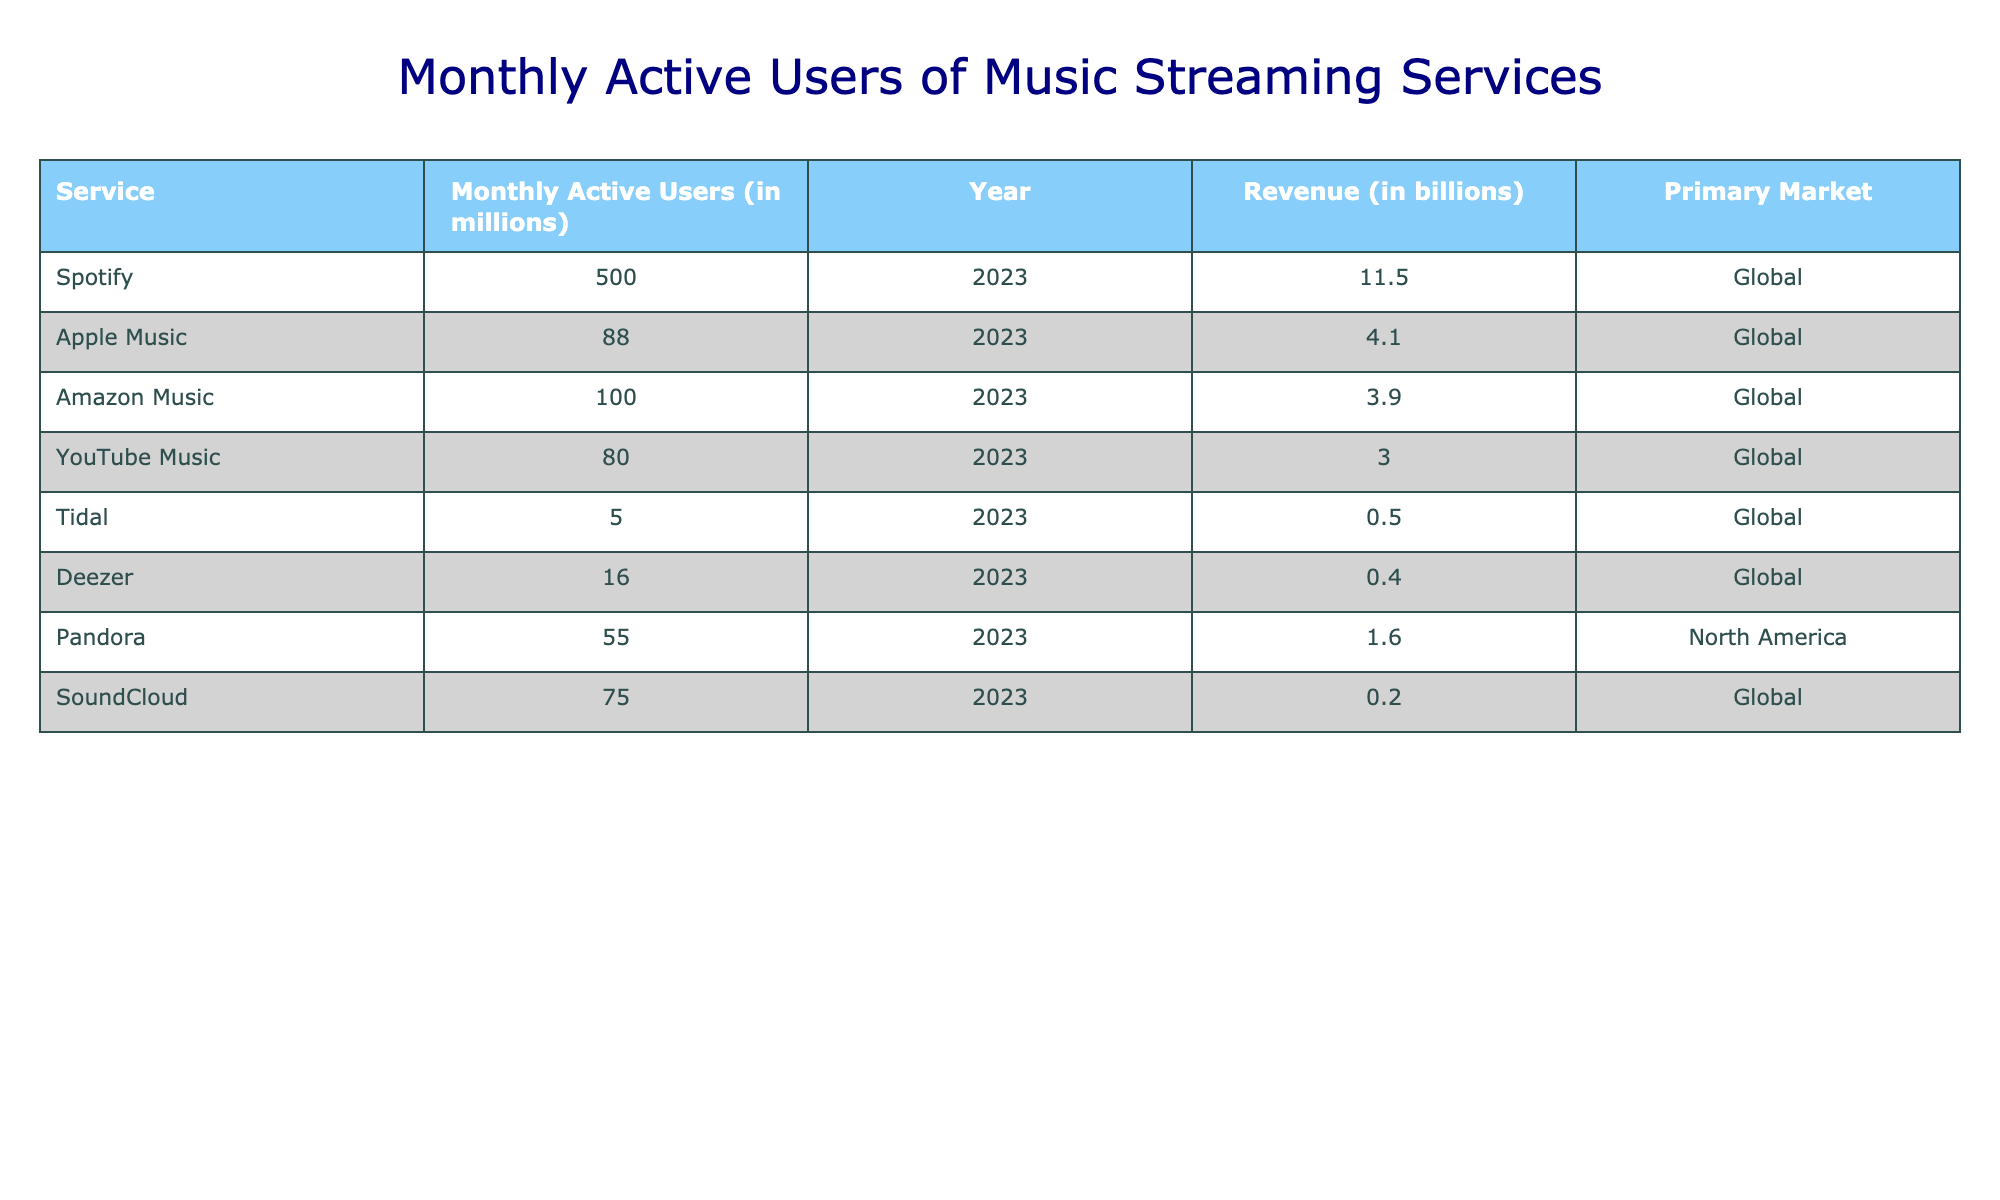What is the Monthly Active Users of Spotify? The table lists Spotify's Monthly Active Users as 500 million in the Year 2023. We can directly refer to the relevant column for Spotify in the table to find this value.
Answer: 500 million Which service has the highest revenue? The table shows the revenue for each service, and Spotify stands out with the highest revenue of 11.5 billion. This can be confirmed by comparing the values in the revenue column.
Answer: Spotify What is the total Monthly Active Users for Apple Music and Amazon Music combined? To find this, we add the Monthly Active Users of Apple Music (88 million) and Amazon Music (100 million). So, 88 + 100 = 188 million. This requires summing the values from the respective rows.
Answer: 188 million Are there more Monthly Active Users for Deezer than for Tidal? When comparing the values, Deezer has 16 million Users while Tidal has 5 million. Since 16 is greater than 5, it confirms that Deezer has more Users than Tidal.
Answer: Yes What is the average Monthly Active Users for all services listed? To calculate the average, first sum the Monthly Active Users: 500 + 88 + 100 + 80 + 5 + 16 + 55 + 75 = 919 million, and then divide by the number of services (8): 919 / 8 = 114.875 million. This requires both addition and division operations.
Answer: 114.875 million Which services have less than 100 million Monthly Active Users? By reviewing the table, we find that the services with less than 100 million Users are Apple Music (88), Amazon Music (100), YouTube Music (80), Tidal (5), Deezer (16), and SoundCloud (75). Tidal is the service with the lowest count. This involves listing out and confirming each service's Monthly Active Users against the threshold of 100 million.
Answer: Apple Music, YouTube Music, Tidal, Deezer, SoundCloud What percentage of total Monthly Active Users does Spotify account for? First, find the total Monthly Active Users which is 919 million. Then calculate the percentage for Spotify by taking (500 / 919) * 100. This results in approximately 54.36%. This question requires both summing and calculating a percentage from the individual value.
Answer: Approximately 54.36% Is the revenue for SoundCloud greater than that of Tidal? From the table, SoundCloud's revenue is 0.2 billion, and Tidal's revenue is 0.5 billion. Since 0.2 is less than 0.5, this confirms that SoundCloud has less revenue than Tidal.
Answer: No What is the difference in Monthly Active Users between Amazon Music and YouTube Music? The Monthly Active Users for Amazon Music is 100 million and for YouTube Music is 80 million. The difference is calculated as 100 - 80 = 20 million. This is a straightforward subtraction operation between two values from the table.
Answer: 20 million 